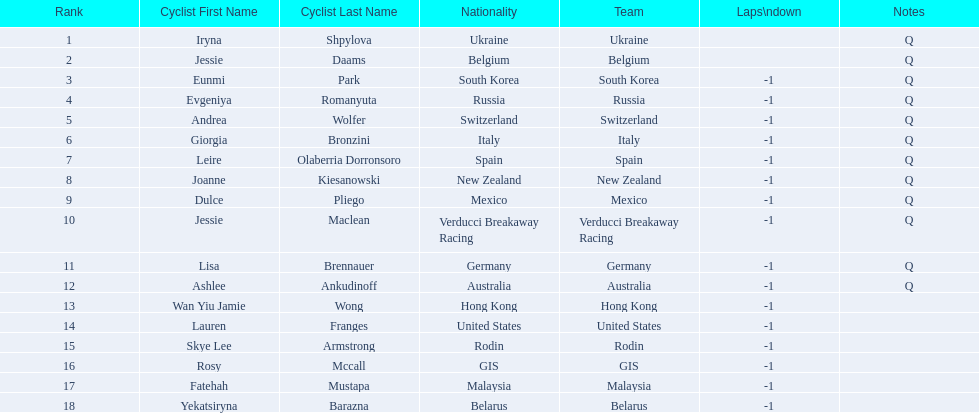How many cyclist do not have -1 laps down? 2. 